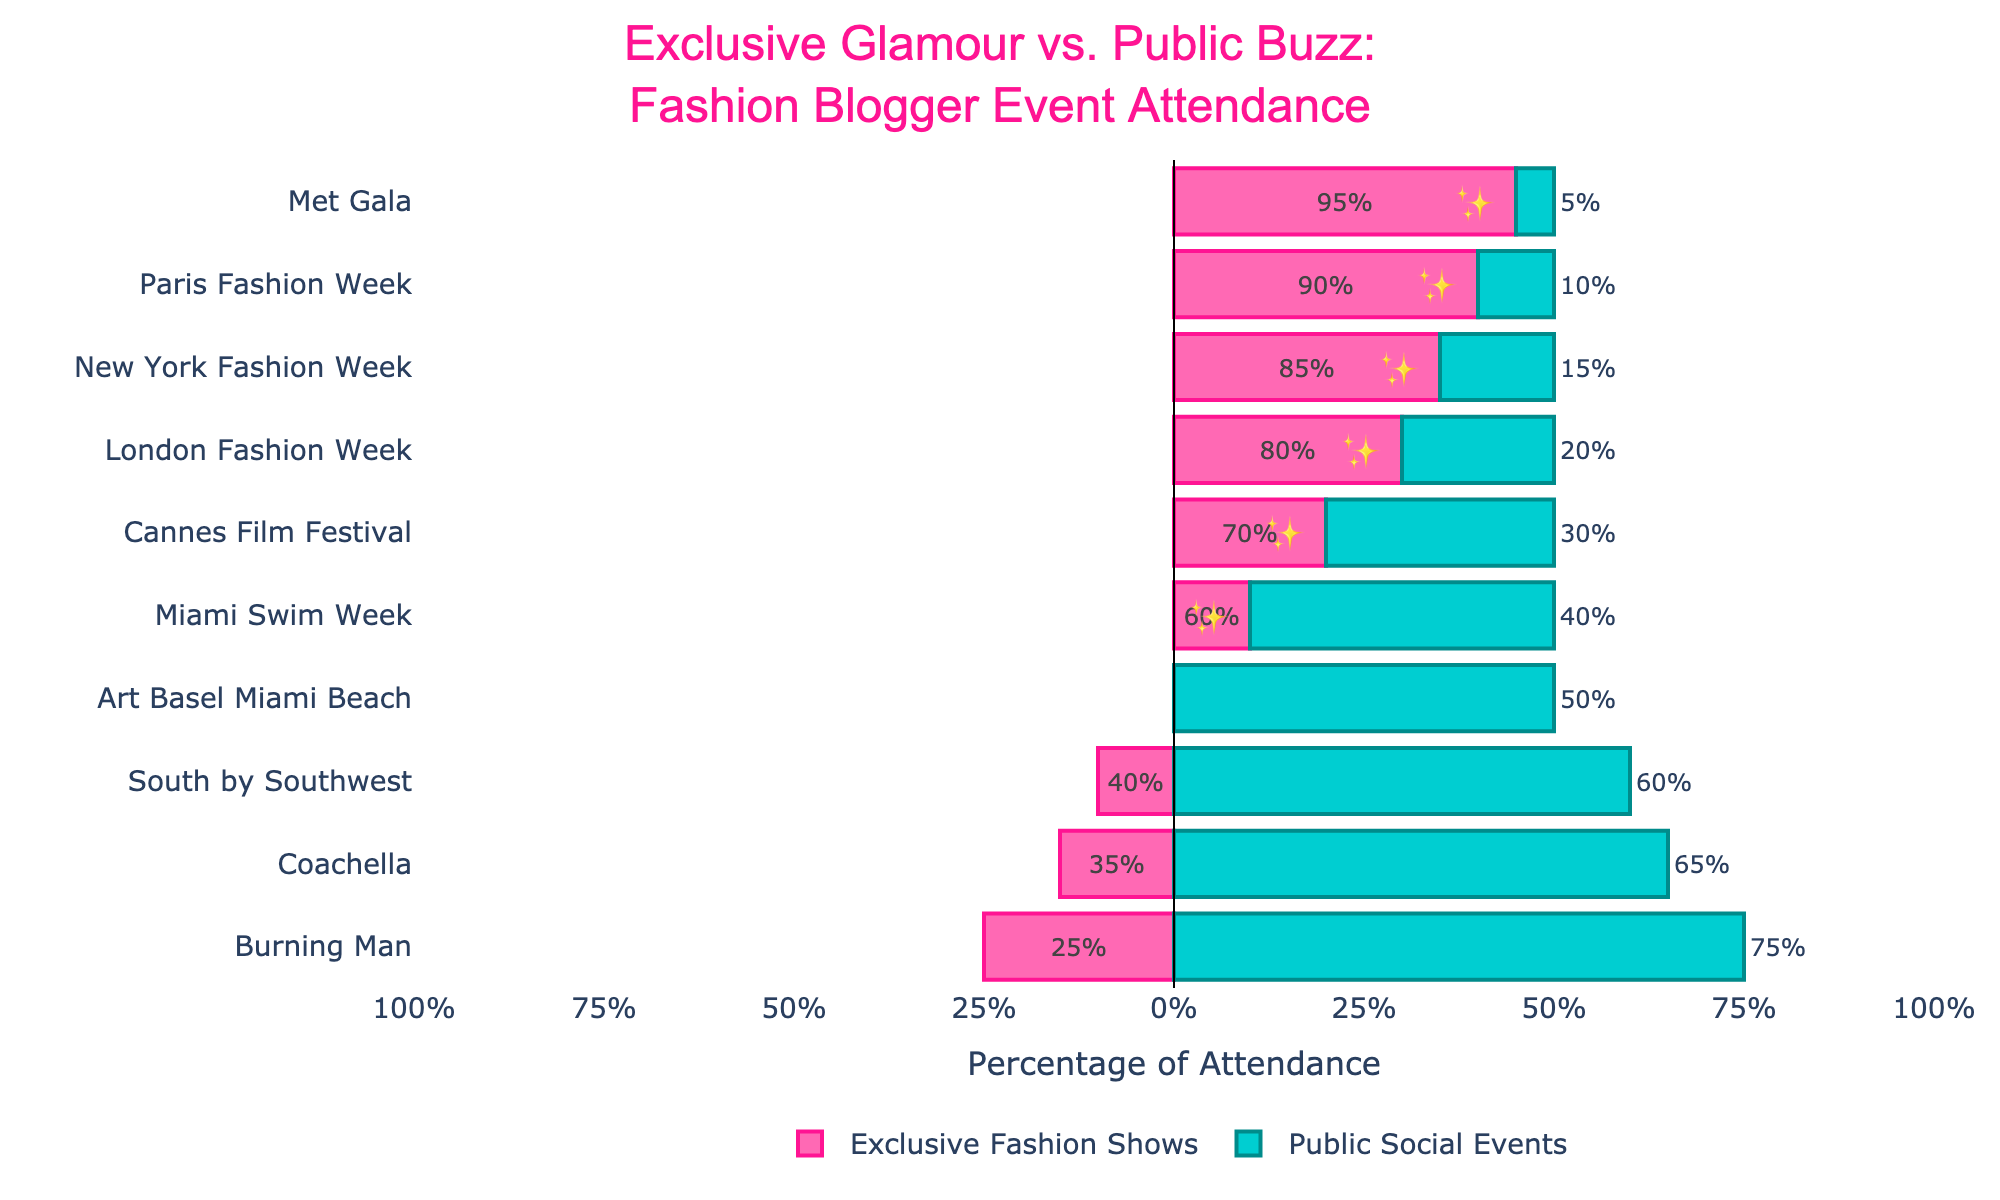Which event has the highest attendance for Public Social Events? Look at the bars colored in blue and identify the longest one. Burning Man has the longest blue bar, indicating the highest attendance at 75%.
Answer: Burning Man Which event is more balanced in terms of attendance between Exclusive Fashion Shows and Public Social Events? Locate the event where the pink and blue bars are closest in length. Art Basel Miami Beach has 50% attendance for both types of events, making it the most balanced.
Answer: Art Basel Miami Beach What is the difference in attendance between Exclusive Fashion Shows and Public Social Events at the Met Gala? Subtract the Public Social Events percentage (5%) from the Exclusive Fashion Shows percentage (95%). The difference is 90%.
Answer: 90% On average, do fashion bloggers attend more Exclusive Fashion Shows or Public Social Events? Add up the percentages for Exclusive Fashion Shows and Public Social Events, then compare the totals. Exclusive Fashion Shows: 585%, Public Social Events: 370%. Divide by the number of events (10) for both. The average for Exclusive Fashion Shows is 58.5%, and for Public Social Events, it is 37%.
Answer: Exclusive Fashion Shows Which event has the lowest attendance for Exclusive Fashion Shows? Look at the bars colored in pink and identify the shortest one. Burning Man has the shortest pink bar, indicating the lowest attendance at 25%.
Answer: Burning Man How many events have more than 50% attendance in Public Social Events? Count all the events where the blue bar exceeds 50%. Coachella, South by Southwest, Art Basel Miami Beach, and Burning Man all have more than 50% attendance in Public Social Events, totaling 4 events.
Answer: 4 What is the total percentage attendance for both types of events at South by Southwest? Add the percentages for Exclusive Fashion Shows (40%) and Public Social Events (60%) at South by Southwest. The total is 100%.
Answer: 100% Which events have an attendance difference of more than 50% between Exclusive Fashion Shows and Public Social Events? Calculate the attendance difference for each event. Met Gala (90%), New York Fashion Week (70%), Paris Fashion Week (80%), and London Fashion Week (60%) all have differences greater than 50%.
Answer: Met Gala, New York Fashion Week, Paris Fashion Week, London Fashion Week Which event has the second-highest percentage attendance for Exclusive Fashion Shows? Identify the second longest pink bar. Paris Fashion Week has the second highest attendance at 90%.
Answer: Paris Fashion Week 